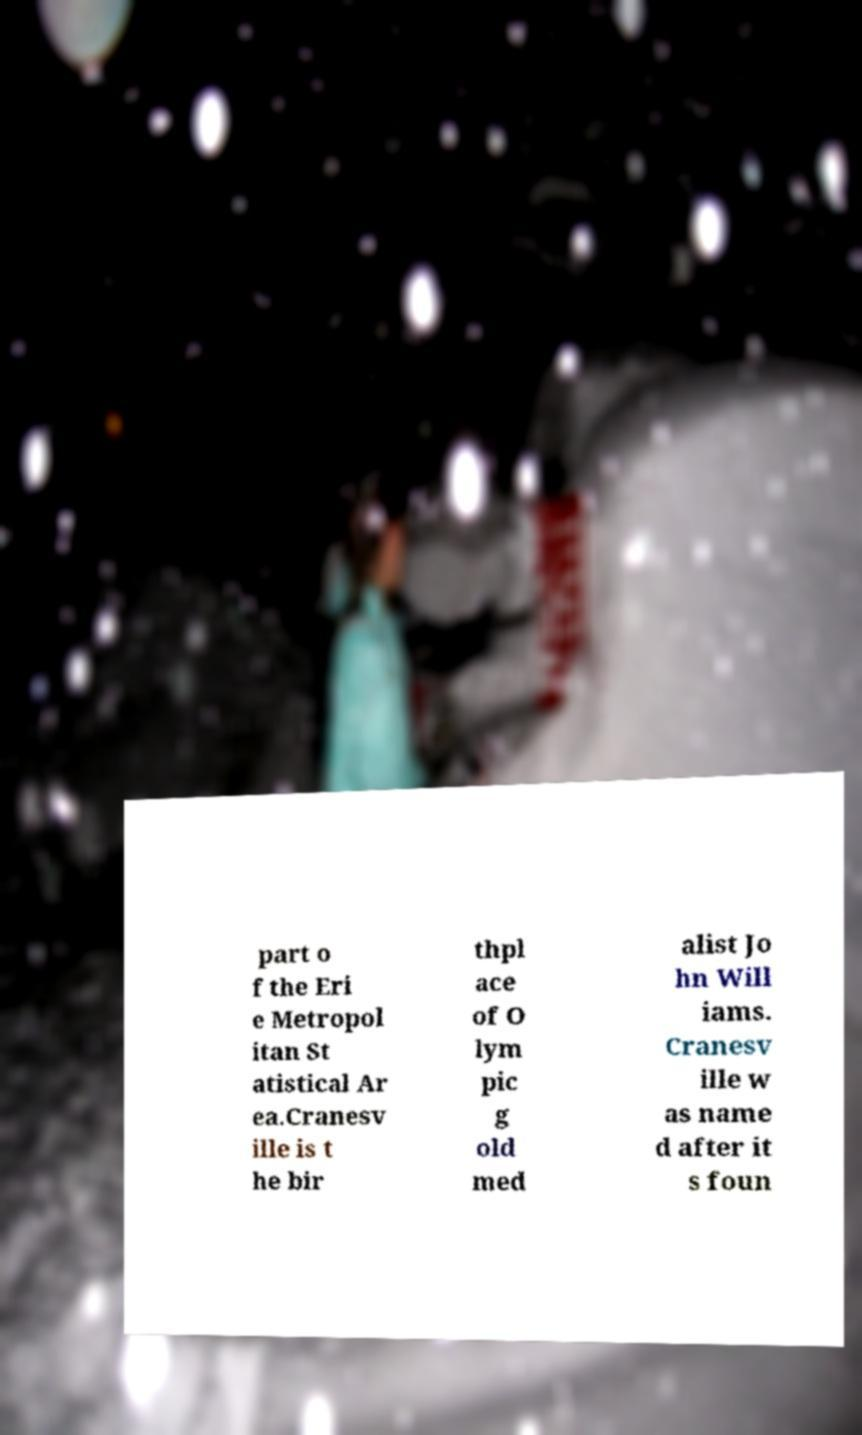For documentation purposes, I need the text within this image transcribed. Could you provide that? part o f the Eri e Metropol itan St atistical Ar ea.Cranesv ille is t he bir thpl ace of O lym pic g old med alist Jo hn Will iams. Cranesv ille w as name d after it s foun 